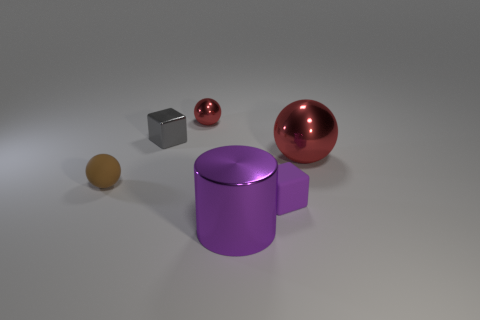Subtract all cyan blocks. How many red spheres are left? 2 Subtract all rubber balls. How many balls are left? 2 Add 3 blocks. How many objects exist? 9 Subtract all blocks. How many objects are left? 4 Subtract 0 cyan spheres. How many objects are left? 6 Subtract all big metallic things. Subtract all large purple metallic things. How many objects are left? 3 Add 6 gray shiny things. How many gray shiny things are left? 7 Add 5 big objects. How many big objects exist? 7 